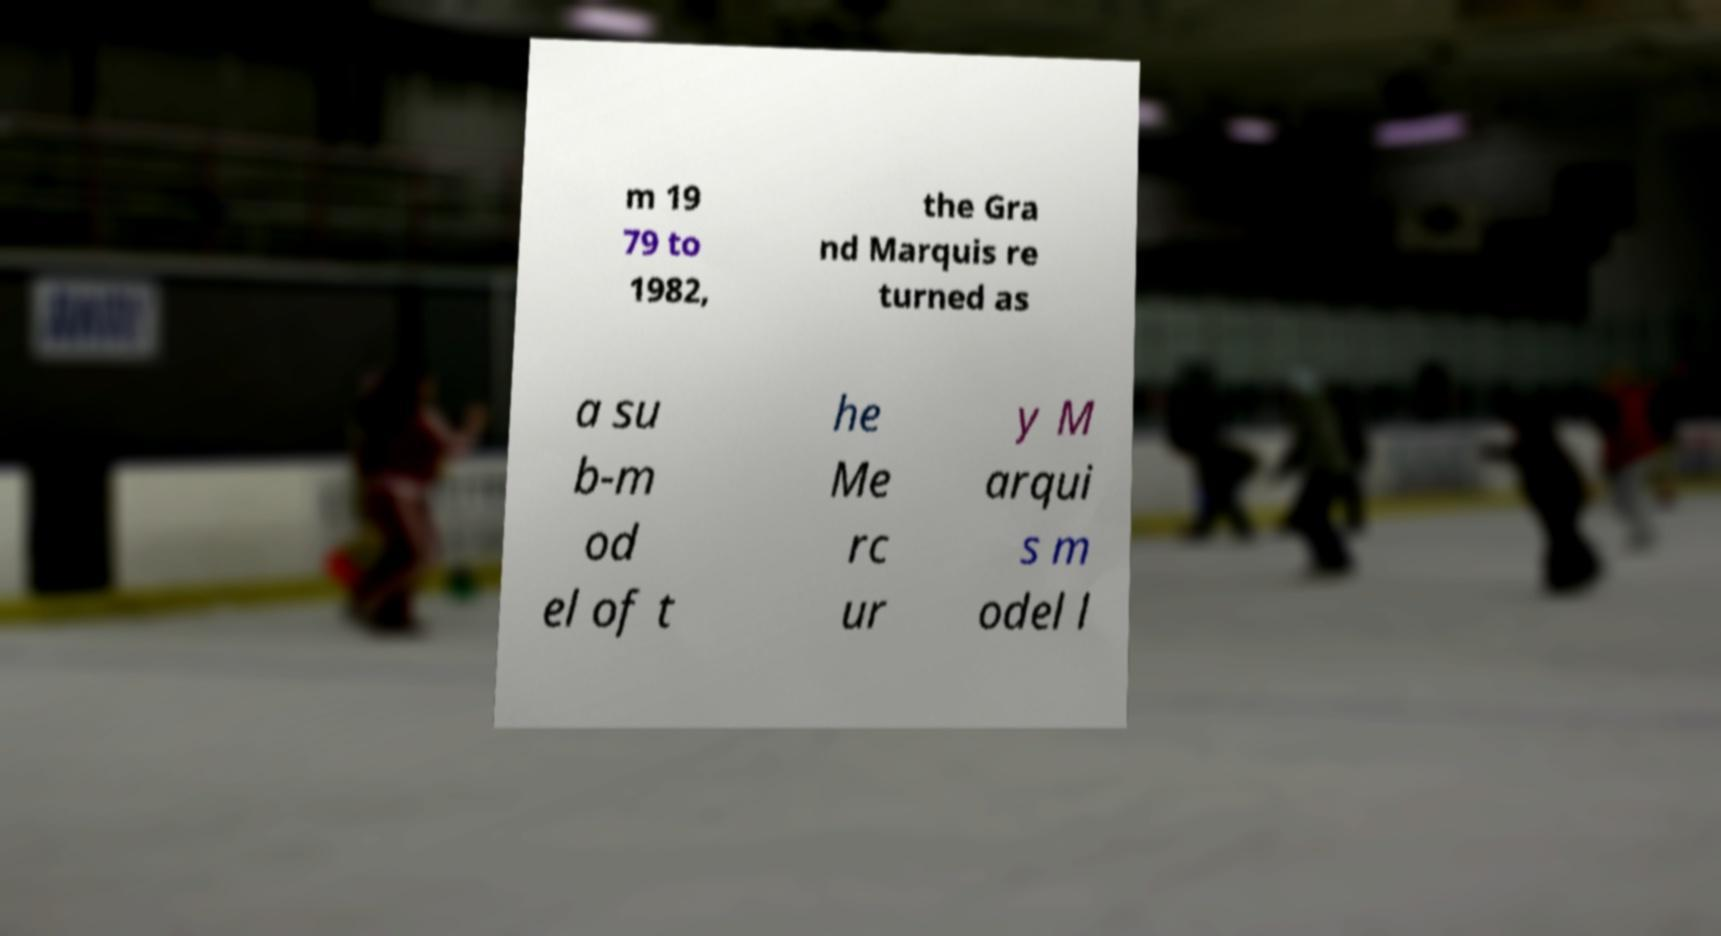Could you assist in decoding the text presented in this image and type it out clearly? m 19 79 to 1982, the Gra nd Marquis re turned as a su b-m od el of t he Me rc ur y M arqui s m odel l 